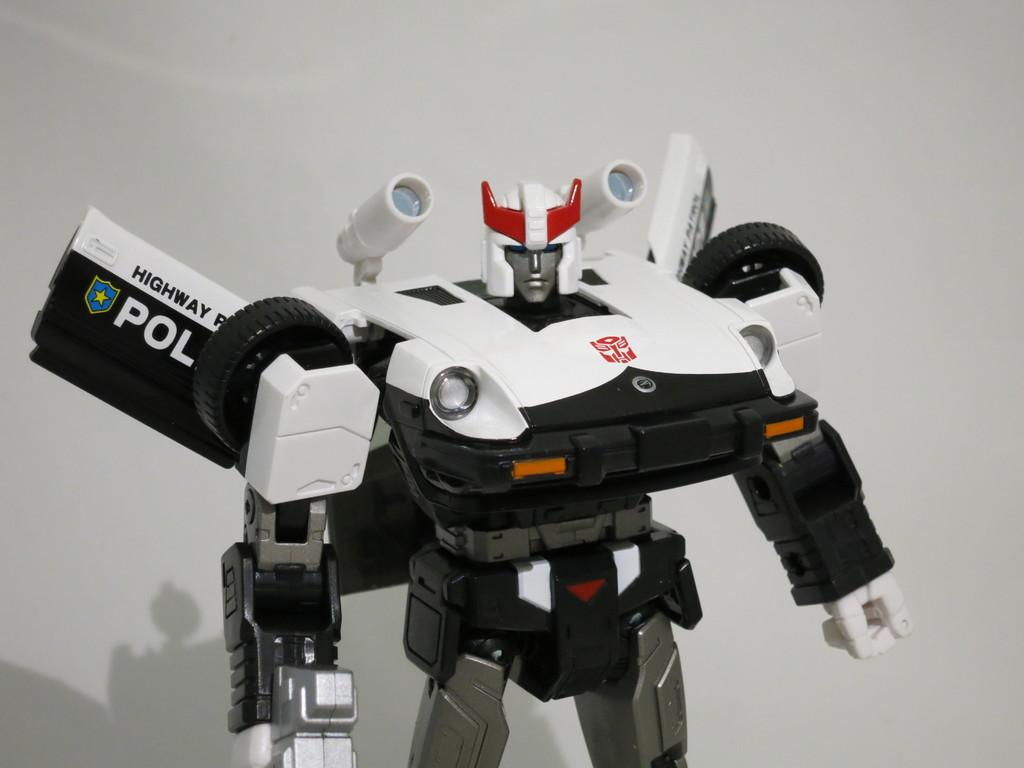<image>
Share a concise interpretation of the image provided. White and black robot with the word HIGHWAY on it's wing. 